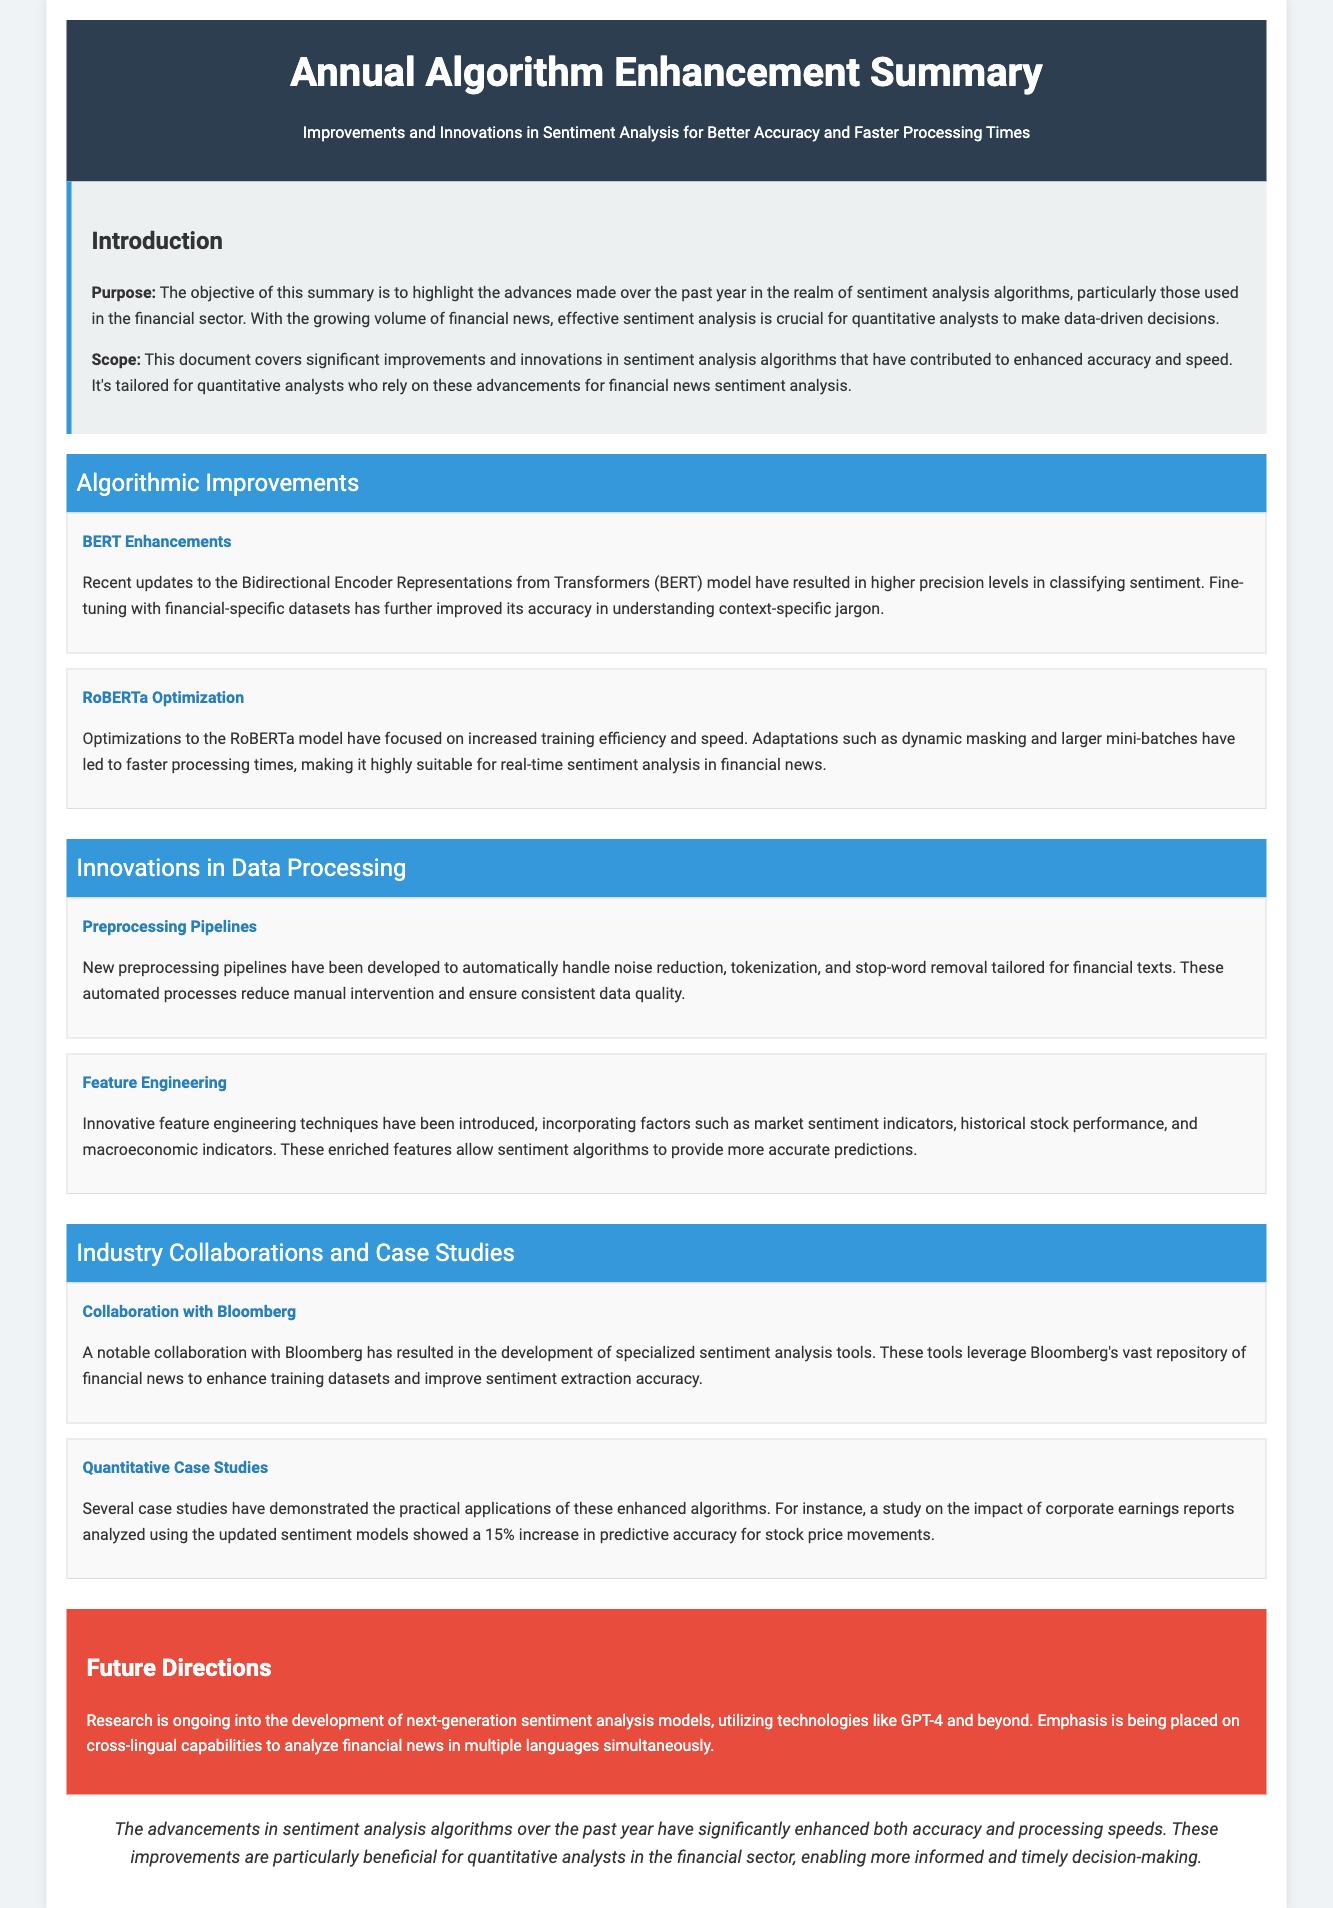What is the purpose of the summary? The purpose of the summary is to highlight the advances made over the past year in sentiment analysis algorithms, particularly those used in the financial sector.
Answer: Highlight advances in sentiment analysis What model underwent enhancements for better sentiment classification? The model that underwent enhancements for better sentiment classification is BERT.
Answer: BERT Which collaboration resulted in specialized sentiment analysis tools? The collaboration that resulted in specialized sentiment analysis tools was with Bloomberg.
Answer: Bloomberg What is one innovative technique in feature engineering mentioned? One innovative technique in feature engineering mentioned incorporates market sentiment indicators.
Answer: Market sentiment indicators What percentage increase in predictive accuracy was observed from the updated sentiment models? The percentage increase in predictive accuracy observed from the updated sentiment models was 15%.
Answer: 15% What are future directions focusing on in sentiment analysis development? Future directions are focusing on cross-lingual capabilities for analyzing financial news in multiple languages.
Answer: Cross-lingual capabilities How has the processing speed changed with the RoBERTa model optimization? The RoBERTa model optimization led to increased training efficiency and speed.
Answer: Increased training efficiency What section discusses the algorithmic improvements? The section that discusses the algorithmic improvements is titled "Algorithmic Improvements."
Answer: Algorithmic Improvements 